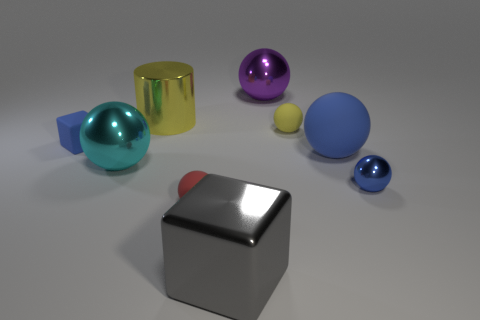How many other cyan things have the same shape as the cyan metal object?
Keep it short and to the point. 0. What is the size of the blue rubber object that is to the left of the matte ball in front of the metal thing on the left side of the large yellow cylinder?
Provide a short and direct response. Small. Are there more tiny blue metal objects in front of the cyan shiny ball than large brown rubber objects?
Keep it short and to the point. Yes. Is there a small gray matte object?
Offer a terse response. No. How many rubber cubes have the same size as the yellow shiny cylinder?
Your answer should be very brief. 0. Is the number of big purple balls that are in front of the gray shiny thing greater than the number of big yellow things to the right of the large yellow shiny object?
Your answer should be compact. No. What is the material of the blue sphere that is the same size as the yellow rubber object?
Give a very brief answer. Metal. There is a large yellow shiny object; what shape is it?
Your answer should be compact. Cylinder. How many red objects are metallic spheres or metallic blocks?
Your answer should be very brief. 0. What is the size of the gray block that is the same material as the purple thing?
Keep it short and to the point. Large. 